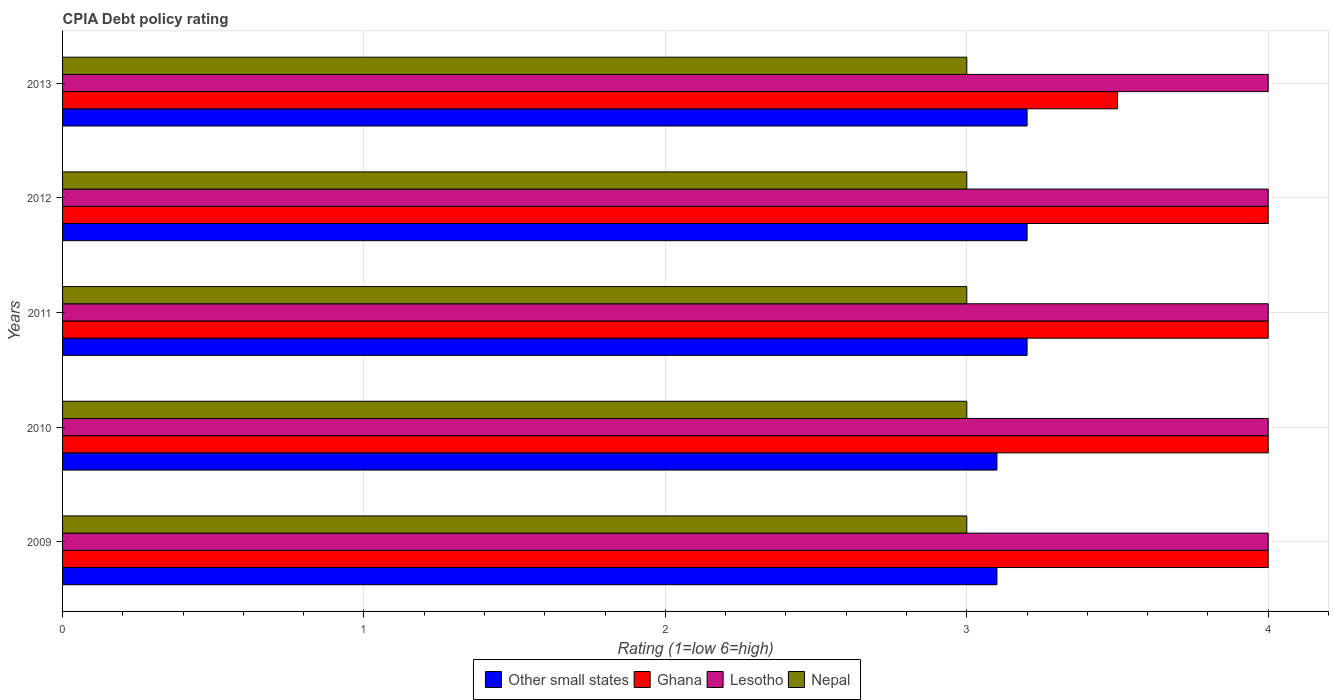How many groups of bars are there?
Your answer should be very brief. 5. Are the number of bars per tick equal to the number of legend labels?
Ensure brevity in your answer.  Yes. How many bars are there on the 3rd tick from the bottom?
Keep it short and to the point. 4. What is the label of the 3rd group of bars from the top?
Your response must be concise. 2011. What is the CPIA rating in Lesotho in 2009?
Keep it short and to the point. 4. In which year was the CPIA rating in Ghana maximum?
Provide a succinct answer. 2009. In which year was the CPIA rating in Ghana minimum?
Ensure brevity in your answer.  2013. What is the total CPIA rating in Ghana in the graph?
Your answer should be very brief. 19.5. What is the difference between the CPIA rating in Other small states in 2009 and that in 2013?
Give a very brief answer. -0.1. What is the difference between the CPIA rating in Other small states in 2013 and the CPIA rating in Lesotho in 2012?
Provide a succinct answer. -0.8. In the year 2010, what is the difference between the CPIA rating in Other small states and CPIA rating in Nepal?
Offer a very short reply. 0.1. In how many years, is the CPIA rating in Other small states greater than 1.4 ?
Make the answer very short. 5. What is the difference between the highest and the lowest CPIA rating in Ghana?
Give a very brief answer. 0.5. What does the 1st bar from the top in 2011 represents?
Keep it short and to the point. Nepal. What does the 1st bar from the bottom in 2012 represents?
Give a very brief answer. Other small states. Are all the bars in the graph horizontal?
Your answer should be compact. Yes. Are the values on the major ticks of X-axis written in scientific E-notation?
Ensure brevity in your answer.  No. Does the graph contain grids?
Your answer should be compact. Yes. Where does the legend appear in the graph?
Offer a very short reply. Bottom center. How many legend labels are there?
Keep it short and to the point. 4. How are the legend labels stacked?
Your response must be concise. Horizontal. What is the title of the graph?
Make the answer very short. CPIA Debt policy rating. What is the label or title of the Y-axis?
Provide a short and direct response. Years. What is the Rating (1=low 6=high) of Other small states in 2010?
Offer a very short reply. 3.1. What is the Rating (1=low 6=high) in Lesotho in 2010?
Make the answer very short. 4. What is the Rating (1=low 6=high) in Other small states in 2011?
Provide a short and direct response. 3.2. What is the Rating (1=low 6=high) of Lesotho in 2011?
Offer a very short reply. 4. What is the Rating (1=low 6=high) in Nepal in 2011?
Provide a succinct answer. 3. What is the Rating (1=low 6=high) in Other small states in 2012?
Make the answer very short. 3.2. What is the Rating (1=low 6=high) of Nepal in 2012?
Offer a very short reply. 3. Across all years, what is the maximum Rating (1=low 6=high) in Ghana?
Offer a terse response. 4. Across all years, what is the maximum Rating (1=low 6=high) in Nepal?
Provide a succinct answer. 3. Across all years, what is the minimum Rating (1=low 6=high) of Ghana?
Offer a terse response. 3.5. Across all years, what is the minimum Rating (1=low 6=high) in Nepal?
Keep it short and to the point. 3. What is the total Rating (1=low 6=high) in Nepal in the graph?
Provide a short and direct response. 15. What is the difference between the Rating (1=low 6=high) of Ghana in 2009 and that in 2010?
Offer a terse response. 0. What is the difference between the Rating (1=low 6=high) of Nepal in 2009 and that in 2010?
Your answer should be very brief. 0. What is the difference between the Rating (1=low 6=high) of Other small states in 2009 and that in 2011?
Provide a succinct answer. -0.1. What is the difference between the Rating (1=low 6=high) of Ghana in 2009 and that in 2011?
Provide a succinct answer. 0. What is the difference between the Rating (1=low 6=high) of Lesotho in 2009 and that in 2012?
Provide a succinct answer. 0. What is the difference between the Rating (1=low 6=high) of Other small states in 2009 and that in 2013?
Your answer should be compact. -0.1. What is the difference between the Rating (1=low 6=high) of Nepal in 2010 and that in 2011?
Offer a terse response. 0. What is the difference between the Rating (1=low 6=high) of Ghana in 2010 and that in 2012?
Provide a succinct answer. 0. What is the difference between the Rating (1=low 6=high) in Lesotho in 2010 and that in 2012?
Your response must be concise. 0. What is the difference between the Rating (1=low 6=high) of Ghana in 2010 and that in 2013?
Your answer should be compact. 0.5. What is the difference between the Rating (1=low 6=high) of Lesotho in 2010 and that in 2013?
Ensure brevity in your answer.  0. What is the difference between the Rating (1=low 6=high) of Other small states in 2011 and that in 2012?
Provide a succinct answer. 0. What is the difference between the Rating (1=low 6=high) of Other small states in 2011 and that in 2013?
Offer a very short reply. 0. What is the difference between the Rating (1=low 6=high) of Lesotho in 2011 and that in 2013?
Offer a very short reply. 0. What is the difference between the Rating (1=low 6=high) in Nepal in 2011 and that in 2013?
Make the answer very short. 0. What is the difference between the Rating (1=low 6=high) of Lesotho in 2012 and that in 2013?
Keep it short and to the point. 0. What is the difference between the Rating (1=low 6=high) in Other small states in 2009 and the Rating (1=low 6=high) in Ghana in 2010?
Offer a very short reply. -0.9. What is the difference between the Rating (1=low 6=high) of Other small states in 2009 and the Rating (1=low 6=high) of Lesotho in 2010?
Your answer should be compact. -0.9. What is the difference between the Rating (1=low 6=high) of Ghana in 2009 and the Rating (1=low 6=high) of Nepal in 2010?
Your answer should be very brief. 1. What is the difference between the Rating (1=low 6=high) in Lesotho in 2009 and the Rating (1=low 6=high) in Nepal in 2010?
Your response must be concise. 1. What is the difference between the Rating (1=low 6=high) of Other small states in 2009 and the Rating (1=low 6=high) of Nepal in 2011?
Your answer should be very brief. 0.1. What is the difference between the Rating (1=low 6=high) in Lesotho in 2009 and the Rating (1=low 6=high) in Nepal in 2011?
Offer a terse response. 1. What is the difference between the Rating (1=low 6=high) in Ghana in 2009 and the Rating (1=low 6=high) in Lesotho in 2012?
Your response must be concise. 0. What is the difference between the Rating (1=low 6=high) in Ghana in 2009 and the Rating (1=low 6=high) in Lesotho in 2013?
Provide a short and direct response. 0. What is the difference between the Rating (1=low 6=high) of Ghana in 2009 and the Rating (1=low 6=high) of Nepal in 2013?
Your response must be concise. 1. What is the difference between the Rating (1=low 6=high) of Lesotho in 2009 and the Rating (1=low 6=high) of Nepal in 2013?
Offer a very short reply. 1. What is the difference between the Rating (1=low 6=high) of Other small states in 2010 and the Rating (1=low 6=high) of Ghana in 2011?
Offer a very short reply. -0.9. What is the difference between the Rating (1=low 6=high) in Other small states in 2010 and the Rating (1=low 6=high) in Lesotho in 2011?
Your response must be concise. -0.9. What is the difference between the Rating (1=low 6=high) in Ghana in 2010 and the Rating (1=low 6=high) in Lesotho in 2011?
Your response must be concise. 0. What is the difference between the Rating (1=low 6=high) in Other small states in 2010 and the Rating (1=low 6=high) in Ghana in 2012?
Your answer should be compact. -0.9. What is the difference between the Rating (1=low 6=high) in Other small states in 2010 and the Rating (1=low 6=high) in Lesotho in 2012?
Keep it short and to the point. -0.9. What is the difference between the Rating (1=low 6=high) of Other small states in 2010 and the Rating (1=low 6=high) of Nepal in 2012?
Make the answer very short. 0.1. What is the difference between the Rating (1=low 6=high) in Ghana in 2010 and the Rating (1=low 6=high) in Lesotho in 2012?
Offer a terse response. 0. What is the difference between the Rating (1=low 6=high) of Ghana in 2010 and the Rating (1=low 6=high) of Nepal in 2012?
Offer a very short reply. 1. What is the difference between the Rating (1=low 6=high) of Lesotho in 2010 and the Rating (1=low 6=high) of Nepal in 2012?
Provide a short and direct response. 1. What is the difference between the Rating (1=low 6=high) in Ghana in 2010 and the Rating (1=low 6=high) in Nepal in 2013?
Your response must be concise. 1. What is the difference between the Rating (1=low 6=high) in Other small states in 2011 and the Rating (1=low 6=high) in Nepal in 2013?
Keep it short and to the point. 0.2. What is the average Rating (1=low 6=high) of Other small states per year?
Provide a short and direct response. 3.16. What is the average Rating (1=low 6=high) of Lesotho per year?
Offer a very short reply. 4. In the year 2009, what is the difference between the Rating (1=low 6=high) of Ghana and Rating (1=low 6=high) of Lesotho?
Give a very brief answer. 0. In the year 2009, what is the difference between the Rating (1=low 6=high) in Ghana and Rating (1=low 6=high) in Nepal?
Your answer should be very brief. 1. In the year 2009, what is the difference between the Rating (1=low 6=high) of Lesotho and Rating (1=low 6=high) of Nepal?
Keep it short and to the point. 1. In the year 2011, what is the difference between the Rating (1=low 6=high) in Other small states and Rating (1=low 6=high) in Ghana?
Your answer should be very brief. -0.8. In the year 2011, what is the difference between the Rating (1=low 6=high) of Other small states and Rating (1=low 6=high) of Lesotho?
Offer a terse response. -0.8. In the year 2011, what is the difference between the Rating (1=low 6=high) of Ghana and Rating (1=low 6=high) of Lesotho?
Ensure brevity in your answer.  0. In the year 2011, what is the difference between the Rating (1=low 6=high) in Ghana and Rating (1=low 6=high) in Nepal?
Provide a short and direct response. 1. In the year 2012, what is the difference between the Rating (1=low 6=high) of Other small states and Rating (1=low 6=high) of Ghana?
Offer a very short reply. -0.8. In the year 2012, what is the difference between the Rating (1=low 6=high) of Other small states and Rating (1=low 6=high) of Lesotho?
Your answer should be compact. -0.8. In the year 2013, what is the difference between the Rating (1=low 6=high) of Other small states and Rating (1=low 6=high) of Lesotho?
Provide a succinct answer. -0.8. What is the ratio of the Rating (1=low 6=high) of Other small states in 2009 to that in 2010?
Offer a terse response. 1. What is the ratio of the Rating (1=low 6=high) in Lesotho in 2009 to that in 2010?
Your answer should be very brief. 1. What is the ratio of the Rating (1=low 6=high) of Nepal in 2009 to that in 2010?
Offer a very short reply. 1. What is the ratio of the Rating (1=low 6=high) in Other small states in 2009 to that in 2011?
Your answer should be very brief. 0.97. What is the ratio of the Rating (1=low 6=high) of Ghana in 2009 to that in 2011?
Your response must be concise. 1. What is the ratio of the Rating (1=low 6=high) of Lesotho in 2009 to that in 2011?
Offer a terse response. 1. What is the ratio of the Rating (1=low 6=high) of Other small states in 2009 to that in 2012?
Offer a very short reply. 0.97. What is the ratio of the Rating (1=low 6=high) of Ghana in 2009 to that in 2012?
Your response must be concise. 1. What is the ratio of the Rating (1=low 6=high) of Nepal in 2009 to that in 2012?
Make the answer very short. 1. What is the ratio of the Rating (1=low 6=high) of Other small states in 2009 to that in 2013?
Provide a succinct answer. 0.97. What is the ratio of the Rating (1=low 6=high) in Ghana in 2009 to that in 2013?
Provide a short and direct response. 1.14. What is the ratio of the Rating (1=low 6=high) in Other small states in 2010 to that in 2011?
Your answer should be very brief. 0.97. What is the ratio of the Rating (1=low 6=high) in Nepal in 2010 to that in 2011?
Offer a terse response. 1. What is the ratio of the Rating (1=low 6=high) of Other small states in 2010 to that in 2012?
Give a very brief answer. 0.97. What is the ratio of the Rating (1=low 6=high) of Ghana in 2010 to that in 2012?
Keep it short and to the point. 1. What is the ratio of the Rating (1=low 6=high) of Lesotho in 2010 to that in 2012?
Give a very brief answer. 1. What is the ratio of the Rating (1=low 6=high) in Other small states in 2010 to that in 2013?
Provide a short and direct response. 0.97. What is the ratio of the Rating (1=low 6=high) in Ghana in 2010 to that in 2013?
Your response must be concise. 1.14. What is the ratio of the Rating (1=low 6=high) in Lesotho in 2010 to that in 2013?
Keep it short and to the point. 1. What is the ratio of the Rating (1=low 6=high) in Ghana in 2011 to that in 2012?
Provide a short and direct response. 1. What is the ratio of the Rating (1=low 6=high) in Lesotho in 2011 to that in 2012?
Ensure brevity in your answer.  1. What is the ratio of the Rating (1=low 6=high) of Nepal in 2011 to that in 2012?
Give a very brief answer. 1. What is the ratio of the Rating (1=low 6=high) of Other small states in 2012 to that in 2013?
Ensure brevity in your answer.  1. What is the ratio of the Rating (1=low 6=high) of Ghana in 2012 to that in 2013?
Your answer should be very brief. 1.14. What is the ratio of the Rating (1=low 6=high) in Nepal in 2012 to that in 2013?
Offer a very short reply. 1. What is the difference between the highest and the second highest Rating (1=low 6=high) in Other small states?
Provide a succinct answer. 0. What is the difference between the highest and the second highest Rating (1=low 6=high) in Ghana?
Keep it short and to the point. 0. What is the difference between the highest and the second highest Rating (1=low 6=high) in Lesotho?
Give a very brief answer. 0. What is the difference between the highest and the second highest Rating (1=low 6=high) of Nepal?
Your response must be concise. 0. What is the difference between the highest and the lowest Rating (1=low 6=high) of Ghana?
Make the answer very short. 0.5. What is the difference between the highest and the lowest Rating (1=low 6=high) in Nepal?
Your answer should be very brief. 0. 